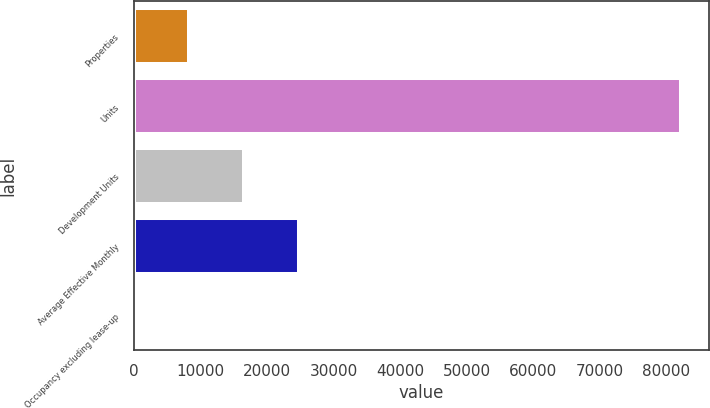Convert chart. <chart><loc_0><loc_0><loc_500><loc_500><bar_chart><fcel>Properties<fcel>Units<fcel>Development Units<fcel>Average Effective Monthly<fcel>Occupancy excluding lease-up<nl><fcel>8316.29<fcel>82316<fcel>16538.5<fcel>24760.7<fcel>94.1<nl></chart> 